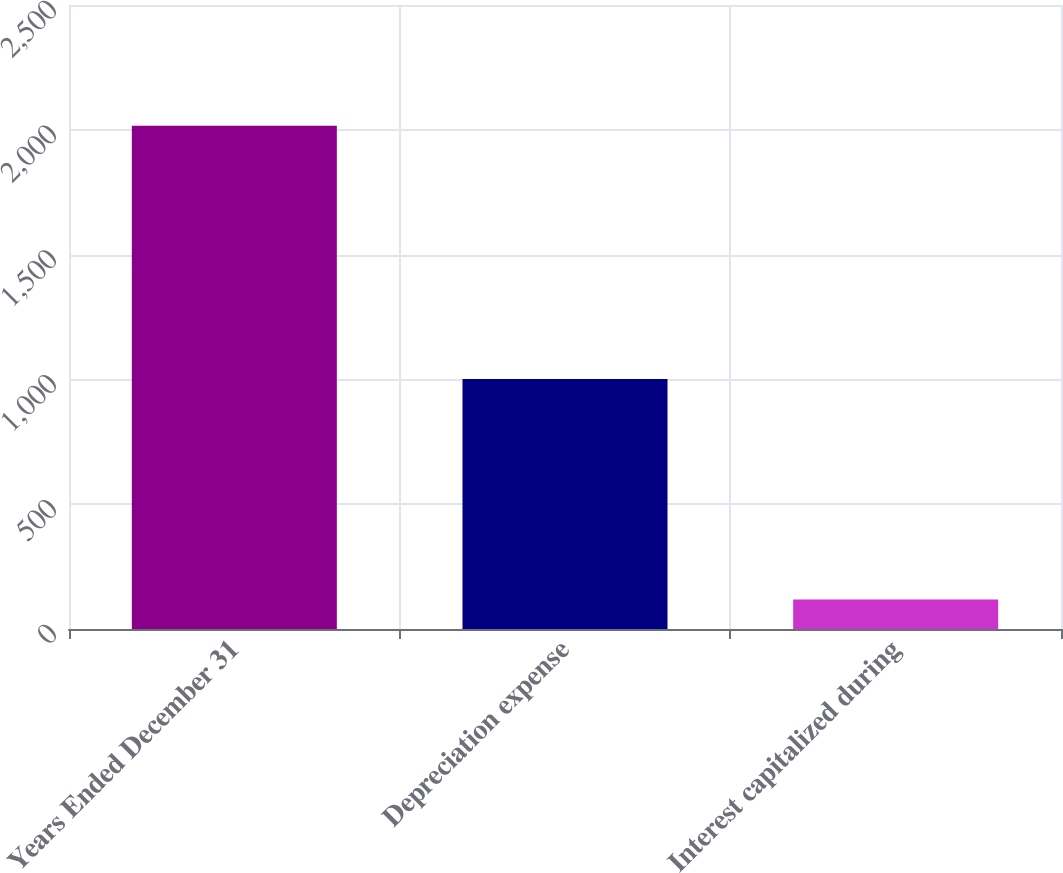Convert chart. <chart><loc_0><loc_0><loc_500><loc_500><bar_chart><fcel>Years Ended December 31<fcel>Depreciation expense<fcel>Interest capitalized during<nl><fcel>2016<fcel>1002<fcel>118<nl></chart> 